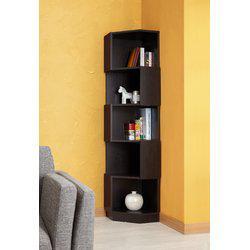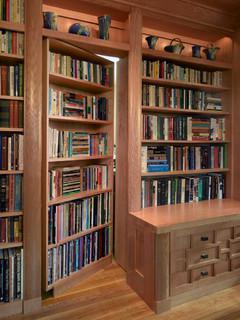The first image is the image on the left, the second image is the image on the right. Evaluate the accuracy of this statement regarding the images: "There is a desk in front of the bookcases in one of the images.". Is it true? Answer yes or no. Yes. 